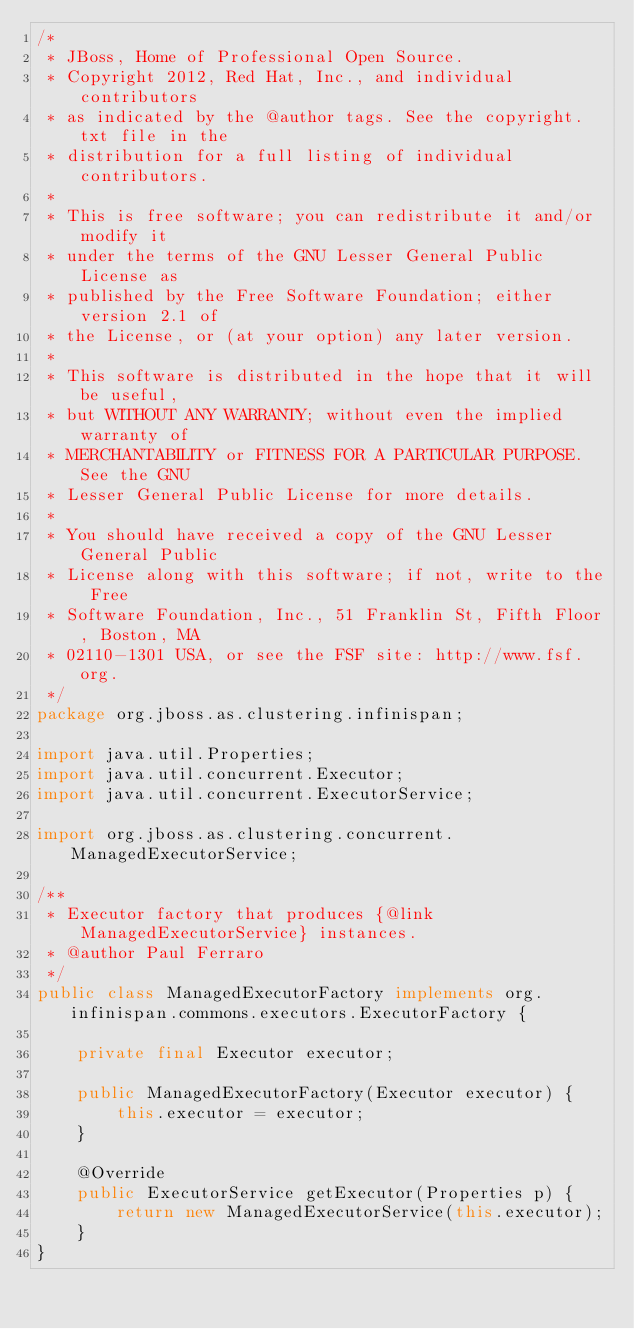<code> <loc_0><loc_0><loc_500><loc_500><_Java_>/*
 * JBoss, Home of Professional Open Source.
 * Copyright 2012, Red Hat, Inc., and individual contributors
 * as indicated by the @author tags. See the copyright.txt file in the
 * distribution for a full listing of individual contributors.
 *
 * This is free software; you can redistribute it and/or modify it
 * under the terms of the GNU Lesser General Public License as
 * published by the Free Software Foundation; either version 2.1 of
 * the License, or (at your option) any later version.
 *
 * This software is distributed in the hope that it will be useful,
 * but WITHOUT ANY WARRANTY; without even the implied warranty of
 * MERCHANTABILITY or FITNESS FOR A PARTICULAR PURPOSE. See the GNU
 * Lesser General Public License for more details.
 *
 * You should have received a copy of the GNU Lesser General Public
 * License along with this software; if not, write to the Free
 * Software Foundation, Inc., 51 Franklin St, Fifth Floor, Boston, MA
 * 02110-1301 USA, or see the FSF site: http://www.fsf.org.
 */
package org.jboss.as.clustering.infinispan;

import java.util.Properties;
import java.util.concurrent.Executor;
import java.util.concurrent.ExecutorService;

import org.jboss.as.clustering.concurrent.ManagedExecutorService;

/**
 * Executor factory that produces {@link ManagedExecutorService} instances.
 * @author Paul Ferraro
 */
public class ManagedExecutorFactory implements org.infinispan.commons.executors.ExecutorFactory {

    private final Executor executor;

    public ManagedExecutorFactory(Executor executor) {
        this.executor = executor;
    }

    @Override
    public ExecutorService getExecutor(Properties p) {
        return new ManagedExecutorService(this.executor);
    }
}
</code> 